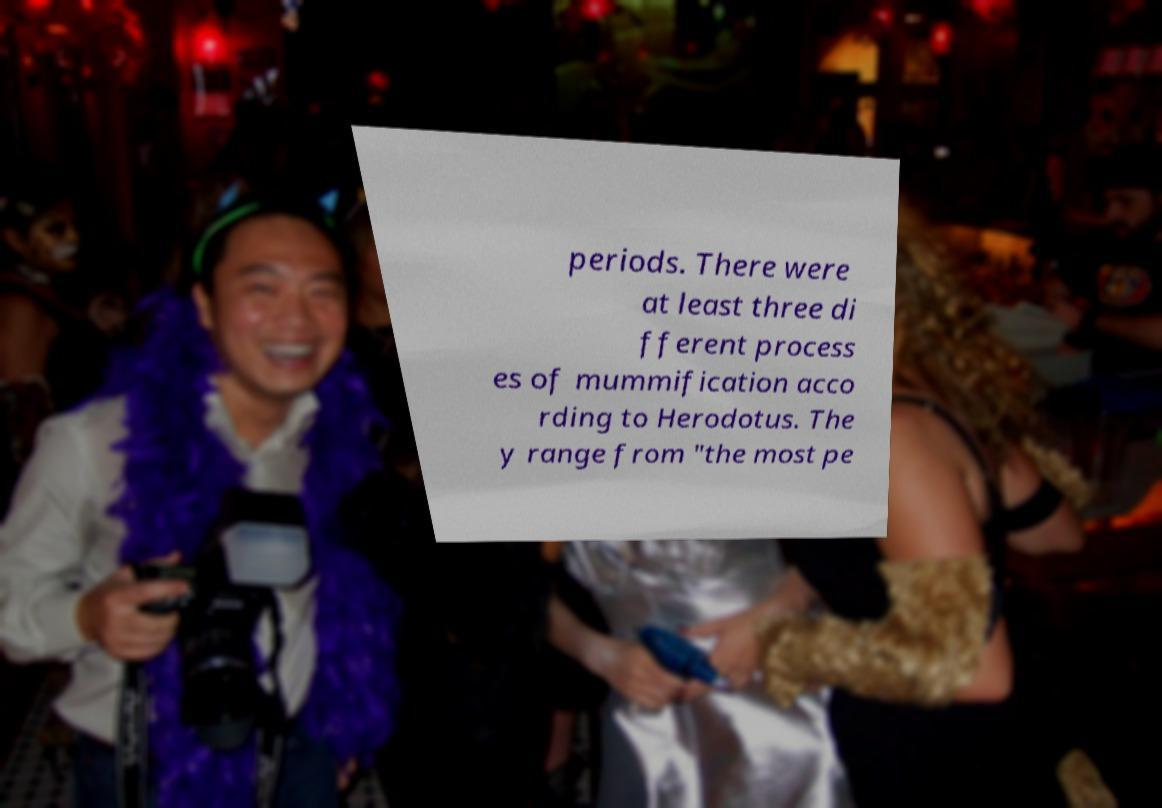Could you assist in decoding the text presented in this image and type it out clearly? periods. There were at least three di fferent process es of mummification acco rding to Herodotus. The y range from "the most pe 